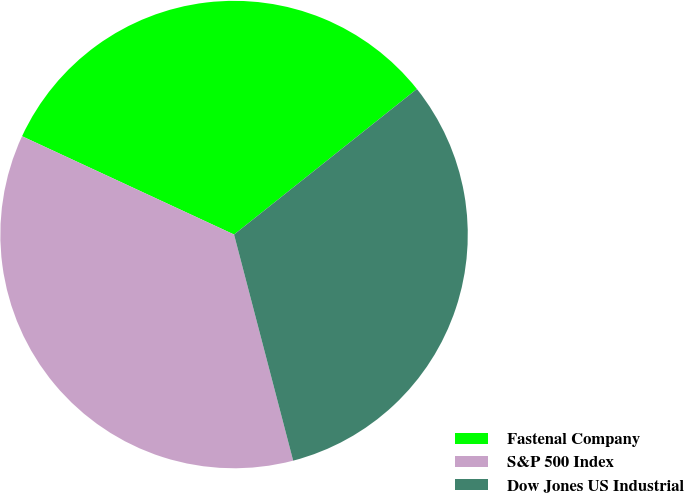<chart> <loc_0><loc_0><loc_500><loc_500><pie_chart><fcel>Fastenal Company<fcel>S&P 500 Index<fcel>Dow Jones US Industrial<nl><fcel>32.39%<fcel>35.98%<fcel>31.63%<nl></chart> 